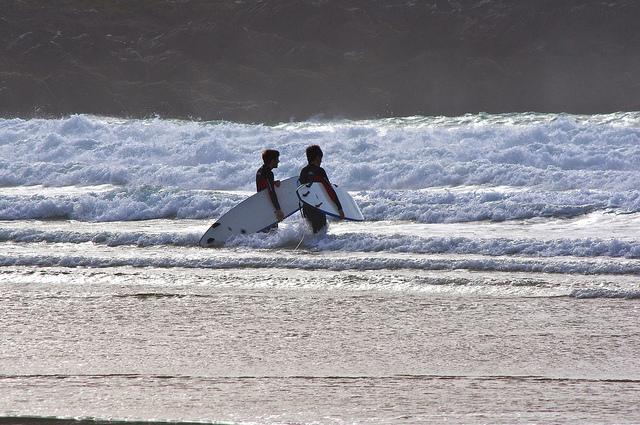What are the two men walking in? water 